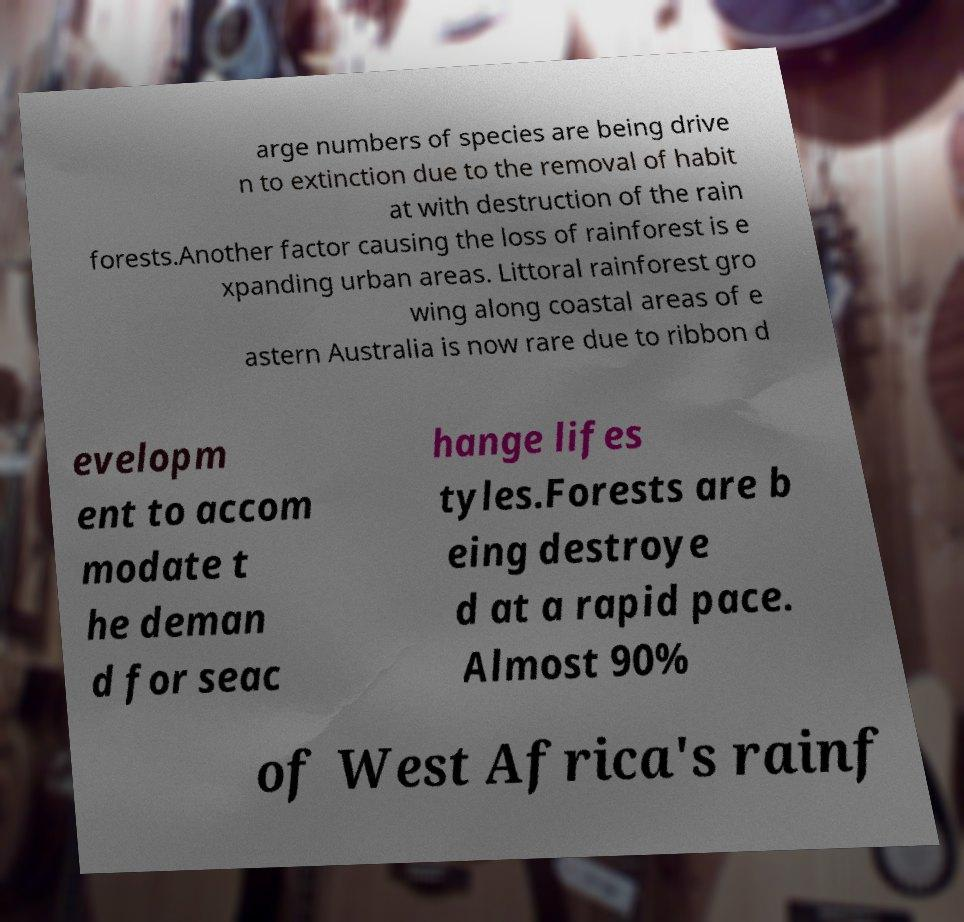Please identify and transcribe the text found in this image. arge numbers of species are being drive n to extinction due to the removal of habit at with destruction of the rain forests.Another factor causing the loss of rainforest is e xpanding urban areas. Littoral rainforest gro wing along coastal areas of e astern Australia is now rare due to ribbon d evelopm ent to accom modate t he deman d for seac hange lifes tyles.Forests are b eing destroye d at a rapid pace. Almost 90% of West Africa's rainf 